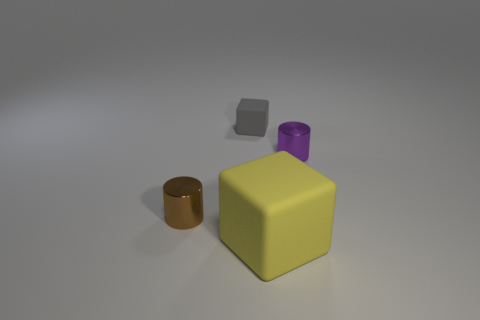Add 1 big matte objects. How many objects exist? 5 Subtract all small red rubber balls. Subtract all small gray rubber blocks. How many objects are left? 3 Add 3 big rubber blocks. How many big rubber blocks are left? 4 Add 4 cylinders. How many cylinders exist? 6 Subtract 0 red spheres. How many objects are left? 4 